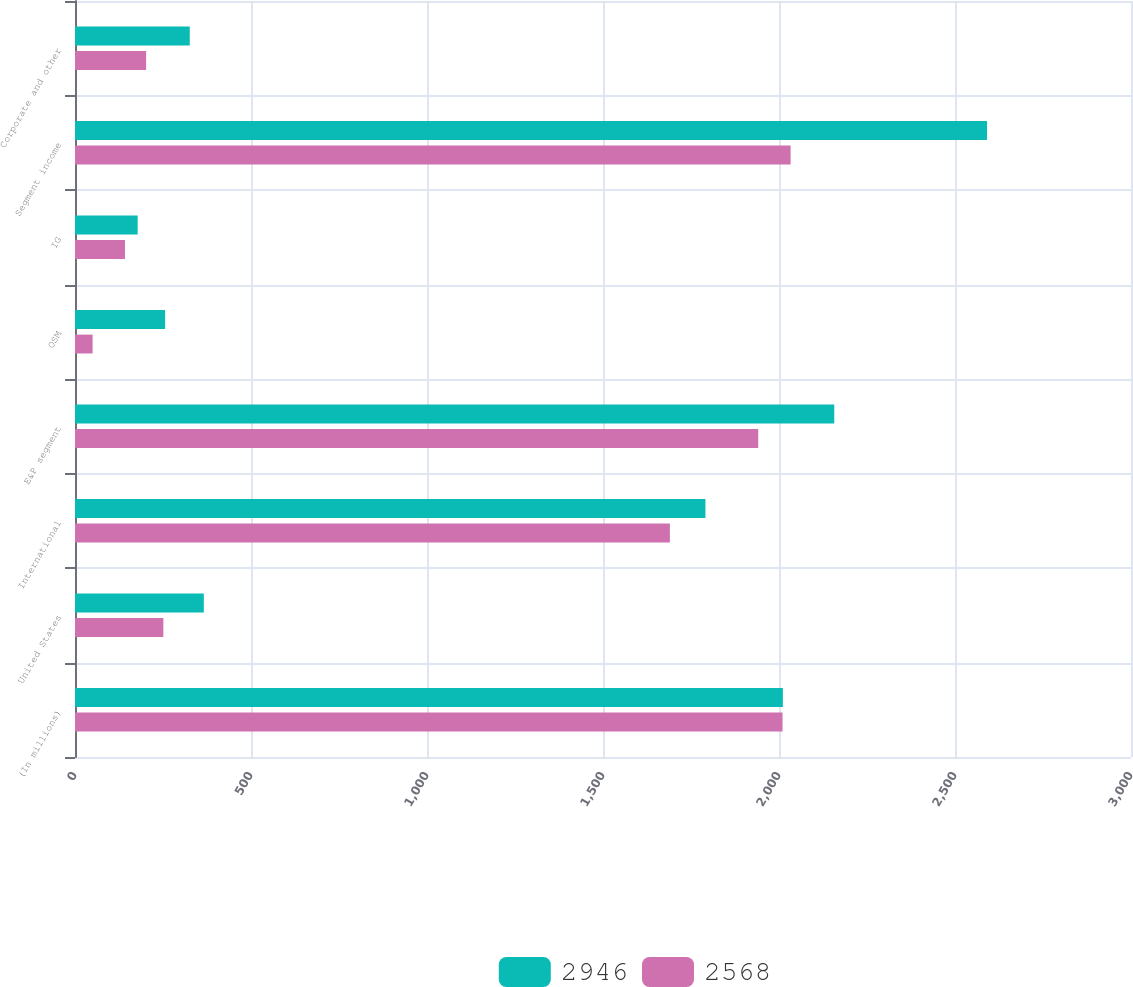Convert chart. <chart><loc_0><loc_0><loc_500><loc_500><stacked_bar_chart><ecel><fcel>(In millions)<fcel>United States<fcel>International<fcel>E&P segment<fcel>OSM<fcel>IG<fcel>Segment income<fcel>Corporate and other<nl><fcel>2946<fcel>2011<fcel>366<fcel>1791<fcel>2157<fcel>256<fcel>178<fcel>2591<fcel>326<nl><fcel>2568<fcel>2010<fcel>251<fcel>1690<fcel>1941<fcel>50<fcel>142<fcel>2033<fcel>202<nl></chart> 